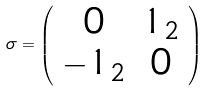Convert formula to latex. <formula><loc_0><loc_0><loc_500><loc_500>\sigma = \left ( \begin{array} { c c } 0 & 1 _ { 2 } \\ - 1 _ { 2 } & 0 \end{array} \right )</formula> 